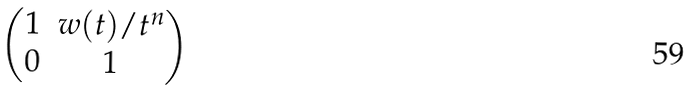<formula> <loc_0><loc_0><loc_500><loc_500>\begin{pmatrix} 1 & w ( t ) / t ^ { n } \\ 0 & 1 \end{pmatrix}</formula> 